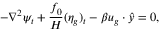Convert formula to latex. <formula><loc_0><loc_0><loc_500><loc_500>- \nabla ^ { 2 } \psi _ { t } + \frac { f _ { 0 } } { H } ( \eta _ { g } ) _ { t } - \beta u _ { g } \cdot \hat { y } = 0 ,</formula> 